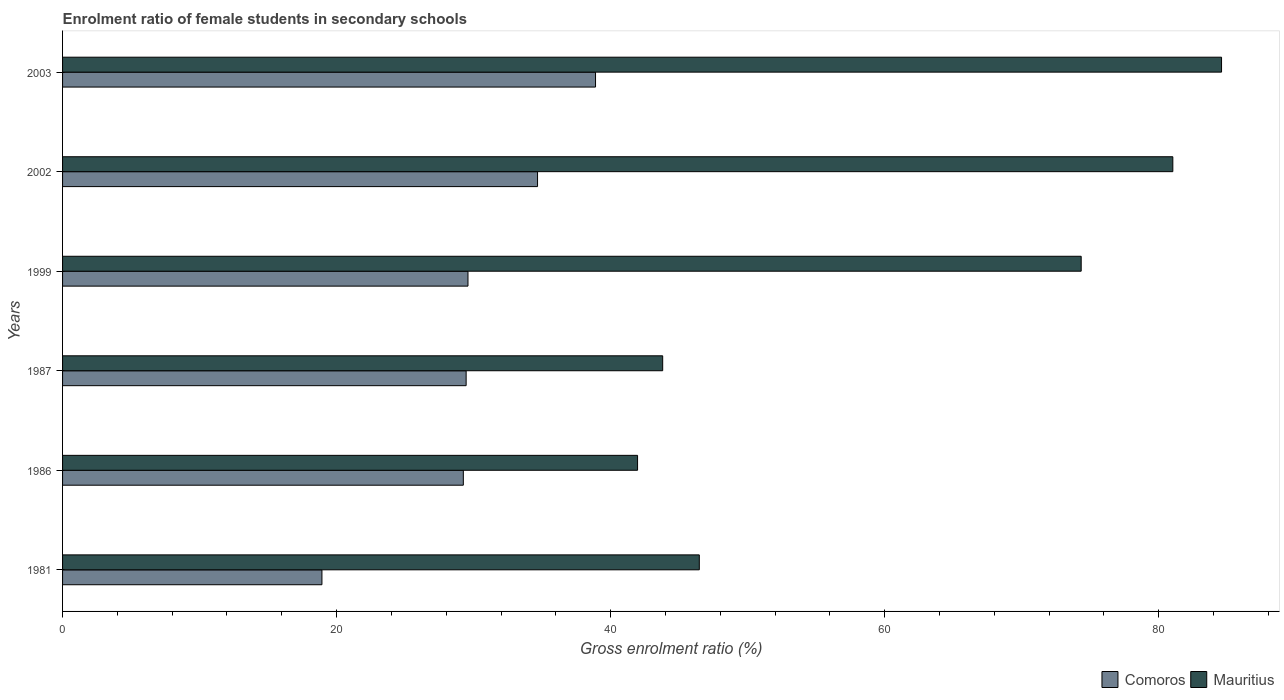Are the number of bars on each tick of the Y-axis equal?
Give a very brief answer. Yes. What is the label of the 2nd group of bars from the top?
Provide a succinct answer. 2002. What is the enrolment ratio of female students in secondary schools in Mauritius in 1999?
Ensure brevity in your answer.  74.34. Across all years, what is the maximum enrolment ratio of female students in secondary schools in Mauritius?
Offer a very short reply. 84.59. Across all years, what is the minimum enrolment ratio of female students in secondary schools in Comoros?
Your answer should be compact. 18.93. In which year was the enrolment ratio of female students in secondary schools in Mauritius maximum?
Your response must be concise. 2003. In which year was the enrolment ratio of female students in secondary schools in Comoros minimum?
Provide a succinct answer. 1981. What is the total enrolment ratio of female students in secondary schools in Comoros in the graph?
Your answer should be very brief. 180.79. What is the difference between the enrolment ratio of female students in secondary schools in Comoros in 1981 and that in 2002?
Your response must be concise. -15.74. What is the difference between the enrolment ratio of female students in secondary schools in Mauritius in 1999 and the enrolment ratio of female students in secondary schools in Comoros in 2002?
Provide a short and direct response. 39.68. What is the average enrolment ratio of female students in secondary schools in Mauritius per year?
Your answer should be very brief. 62.03. In the year 2002, what is the difference between the enrolment ratio of female students in secondary schools in Mauritius and enrolment ratio of female students in secondary schools in Comoros?
Your response must be concise. 46.37. What is the ratio of the enrolment ratio of female students in secondary schools in Mauritius in 1981 to that in 1986?
Give a very brief answer. 1.11. Is the enrolment ratio of female students in secondary schools in Comoros in 1986 less than that in 2003?
Make the answer very short. Yes. What is the difference between the highest and the second highest enrolment ratio of female students in secondary schools in Mauritius?
Ensure brevity in your answer.  3.56. What is the difference between the highest and the lowest enrolment ratio of female students in secondary schools in Mauritius?
Give a very brief answer. 42.62. What does the 2nd bar from the top in 1999 represents?
Offer a terse response. Comoros. What does the 2nd bar from the bottom in 1986 represents?
Your answer should be very brief. Mauritius. Are all the bars in the graph horizontal?
Provide a short and direct response. Yes. How many years are there in the graph?
Give a very brief answer. 6. Are the values on the major ticks of X-axis written in scientific E-notation?
Provide a short and direct response. No. Does the graph contain any zero values?
Your response must be concise. No. Where does the legend appear in the graph?
Your response must be concise. Bottom right. How many legend labels are there?
Give a very brief answer. 2. What is the title of the graph?
Offer a very short reply. Enrolment ratio of female students in secondary schools. What is the Gross enrolment ratio (%) of Comoros in 1981?
Provide a short and direct response. 18.93. What is the Gross enrolment ratio (%) in Mauritius in 1981?
Your answer should be very brief. 46.47. What is the Gross enrolment ratio (%) of Comoros in 1986?
Provide a short and direct response. 29.25. What is the Gross enrolment ratio (%) of Mauritius in 1986?
Offer a terse response. 41.97. What is the Gross enrolment ratio (%) in Comoros in 1987?
Your response must be concise. 29.45. What is the Gross enrolment ratio (%) of Mauritius in 1987?
Offer a terse response. 43.8. What is the Gross enrolment ratio (%) of Comoros in 1999?
Your answer should be compact. 29.59. What is the Gross enrolment ratio (%) in Mauritius in 1999?
Provide a short and direct response. 74.34. What is the Gross enrolment ratio (%) of Comoros in 2002?
Your answer should be very brief. 34.67. What is the Gross enrolment ratio (%) in Mauritius in 2002?
Your response must be concise. 81.03. What is the Gross enrolment ratio (%) in Comoros in 2003?
Give a very brief answer. 38.9. What is the Gross enrolment ratio (%) of Mauritius in 2003?
Make the answer very short. 84.59. Across all years, what is the maximum Gross enrolment ratio (%) in Comoros?
Offer a very short reply. 38.9. Across all years, what is the maximum Gross enrolment ratio (%) in Mauritius?
Your answer should be compact. 84.59. Across all years, what is the minimum Gross enrolment ratio (%) of Comoros?
Offer a very short reply. 18.93. Across all years, what is the minimum Gross enrolment ratio (%) of Mauritius?
Provide a succinct answer. 41.97. What is the total Gross enrolment ratio (%) of Comoros in the graph?
Offer a very short reply. 180.79. What is the total Gross enrolment ratio (%) of Mauritius in the graph?
Your answer should be compact. 372.2. What is the difference between the Gross enrolment ratio (%) of Comoros in 1981 and that in 1986?
Provide a short and direct response. -10.32. What is the difference between the Gross enrolment ratio (%) in Mauritius in 1981 and that in 1986?
Offer a terse response. 4.51. What is the difference between the Gross enrolment ratio (%) of Comoros in 1981 and that in 1987?
Offer a terse response. -10.52. What is the difference between the Gross enrolment ratio (%) of Mauritius in 1981 and that in 1987?
Ensure brevity in your answer.  2.67. What is the difference between the Gross enrolment ratio (%) of Comoros in 1981 and that in 1999?
Offer a very short reply. -10.66. What is the difference between the Gross enrolment ratio (%) of Mauritius in 1981 and that in 1999?
Your response must be concise. -27.87. What is the difference between the Gross enrolment ratio (%) in Comoros in 1981 and that in 2002?
Provide a succinct answer. -15.74. What is the difference between the Gross enrolment ratio (%) of Mauritius in 1981 and that in 2002?
Provide a short and direct response. -34.56. What is the difference between the Gross enrolment ratio (%) in Comoros in 1981 and that in 2003?
Offer a very short reply. -19.97. What is the difference between the Gross enrolment ratio (%) of Mauritius in 1981 and that in 2003?
Offer a very short reply. -38.12. What is the difference between the Gross enrolment ratio (%) in Comoros in 1986 and that in 1987?
Your response must be concise. -0.2. What is the difference between the Gross enrolment ratio (%) of Mauritius in 1986 and that in 1987?
Make the answer very short. -1.83. What is the difference between the Gross enrolment ratio (%) of Comoros in 1986 and that in 1999?
Offer a terse response. -0.34. What is the difference between the Gross enrolment ratio (%) of Mauritius in 1986 and that in 1999?
Your response must be concise. -32.38. What is the difference between the Gross enrolment ratio (%) in Comoros in 1986 and that in 2002?
Ensure brevity in your answer.  -5.42. What is the difference between the Gross enrolment ratio (%) of Mauritius in 1986 and that in 2002?
Provide a succinct answer. -39.07. What is the difference between the Gross enrolment ratio (%) of Comoros in 1986 and that in 2003?
Offer a very short reply. -9.65. What is the difference between the Gross enrolment ratio (%) of Mauritius in 1986 and that in 2003?
Keep it short and to the point. -42.62. What is the difference between the Gross enrolment ratio (%) of Comoros in 1987 and that in 1999?
Provide a succinct answer. -0.13. What is the difference between the Gross enrolment ratio (%) of Mauritius in 1987 and that in 1999?
Your answer should be compact. -30.55. What is the difference between the Gross enrolment ratio (%) of Comoros in 1987 and that in 2002?
Give a very brief answer. -5.21. What is the difference between the Gross enrolment ratio (%) of Mauritius in 1987 and that in 2002?
Give a very brief answer. -37.23. What is the difference between the Gross enrolment ratio (%) of Comoros in 1987 and that in 2003?
Ensure brevity in your answer.  -9.44. What is the difference between the Gross enrolment ratio (%) of Mauritius in 1987 and that in 2003?
Provide a short and direct response. -40.79. What is the difference between the Gross enrolment ratio (%) of Comoros in 1999 and that in 2002?
Make the answer very short. -5.08. What is the difference between the Gross enrolment ratio (%) of Mauritius in 1999 and that in 2002?
Your answer should be compact. -6.69. What is the difference between the Gross enrolment ratio (%) of Comoros in 1999 and that in 2003?
Provide a short and direct response. -9.31. What is the difference between the Gross enrolment ratio (%) of Mauritius in 1999 and that in 2003?
Your answer should be very brief. -10.24. What is the difference between the Gross enrolment ratio (%) in Comoros in 2002 and that in 2003?
Give a very brief answer. -4.23. What is the difference between the Gross enrolment ratio (%) in Mauritius in 2002 and that in 2003?
Make the answer very short. -3.56. What is the difference between the Gross enrolment ratio (%) in Comoros in 1981 and the Gross enrolment ratio (%) in Mauritius in 1986?
Provide a succinct answer. -23.04. What is the difference between the Gross enrolment ratio (%) of Comoros in 1981 and the Gross enrolment ratio (%) of Mauritius in 1987?
Offer a terse response. -24.87. What is the difference between the Gross enrolment ratio (%) in Comoros in 1981 and the Gross enrolment ratio (%) in Mauritius in 1999?
Provide a succinct answer. -55.41. What is the difference between the Gross enrolment ratio (%) of Comoros in 1981 and the Gross enrolment ratio (%) of Mauritius in 2002?
Keep it short and to the point. -62.1. What is the difference between the Gross enrolment ratio (%) of Comoros in 1981 and the Gross enrolment ratio (%) of Mauritius in 2003?
Your response must be concise. -65.66. What is the difference between the Gross enrolment ratio (%) in Comoros in 1986 and the Gross enrolment ratio (%) in Mauritius in 1987?
Provide a succinct answer. -14.55. What is the difference between the Gross enrolment ratio (%) in Comoros in 1986 and the Gross enrolment ratio (%) in Mauritius in 1999?
Ensure brevity in your answer.  -45.09. What is the difference between the Gross enrolment ratio (%) of Comoros in 1986 and the Gross enrolment ratio (%) of Mauritius in 2002?
Make the answer very short. -51.78. What is the difference between the Gross enrolment ratio (%) of Comoros in 1986 and the Gross enrolment ratio (%) of Mauritius in 2003?
Your response must be concise. -55.34. What is the difference between the Gross enrolment ratio (%) in Comoros in 1987 and the Gross enrolment ratio (%) in Mauritius in 1999?
Your response must be concise. -44.89. What is the difference between the Gross enrolment ratio (%) in Comoros in 1987 and the Gross enrolment ratio (%) in Mauritius in 2002?
Ensure brevity in your answer.  -51.58. What is the difference between the Gross enrolment ratio (%) in Comoros in 1987 and the Gross enrolment ratio (%) in Mauritius in 2003?
Your answer should be compact. -55.13. What is the difference between the Gross enrolment ratio (%) in Comoros in 1999 and the Gross enrolment ratio (%) in Mauritius in 2002?
Ensure brevity in your answer.  -51.44. What is the difference between the Gross enrolment ratio (%) in Comoros in 1999 and the Gross enrolment ratio (%) in Mauritius in 2003?
Offer a terse response. -55. What is the difference between the Gross enrolment ratio (%) in Comoros in 2002 and the Gross enrolment ratio (%) in Mauritius in 2003?
Give a very brief answer. -49.92. What is the average Gross enrolment ratio (%) in Comoros per year?
Provide a succinct answer. 30.13. What is the average Gross enrolment ratio (%) of Mauritius per year?
Ensure brevity in your answer.  62.03. In the year 1981, what is the difference between the Gross enrolment ratio (%) of Comoros and Gross enrolment ratio (%) of Mauritius?
Your answer should be very brief. -27.54. In the year 1986, what is the difference between the Gross enrolment ratio (%) in Comoros and Gross enrolment ratio (%) in Mauritius?
Give a very brief answer. -12.72. In the year 1987, what is the difference between the Gross enrolment ratio (%) of Comoros and Gross enrolment ratio (%) of Mauritius?
Offer a terse response. -14.34. In the year 1999, what is the difference between the Gross enrolment ratio (%) in Comoros and Gross enrolment ratio (%) in Mauritius?
Give a very brief answer. -44.76. In the year 2002, what is the difference between the Gross enrolment ratio (%) of Comoros and Gross enrolment ratio (%) of Mauritius?
Your response must be concise. -46.37. In the year 2003, what is the difference between the Gross enrolment ratio (%) in Comoros and Gross enrolment ratio (%) in Mauritius?
Provide a short and direct response. -45.69. What is the ratio of the Gross enrolment ratio (%) in Comoros in 1981 to that in 1986?
Give a very brief answer. 0.65. What is the ratio of the Gross enrolment ratio (%) in Mauritius in 1981 to that in 1986?
Keep it short and to the point. 1.11. What is the ratio of the Gross enrolment ratio (%) in Comoros in 1981 to that in 1987?
Ensure brevity in your answer.  0.64. What is the ratio of the Gross enrolment ratio (%) in Mauritius in 1981 to that in 1987?
Keep it short and to the point. 1.06. What is the ratio of the Gross enrolment ratio (%) of Comoros in 1981 to that in 1999?
Your answer should be compact. 0.64. What is the ratio of the Gross enrolment ratio (%) of Mauritius in 1981 to that in 1999?
Your response must be concise. 0.63. What is the ratio of the Gross enrolment ratio (%) of Comoros in 1981 to that in 2002?
Offer a very short reply. 0.55. What is the ratio of the Gross enrolment ratio (%) of Mauritius in 1981 to that in 2002?
Keep it short and to the point. 0.57. What is the ratio of the Gross enrolment ratio (%) of Comoros in 1981 to that in 2003?
Your answer should be very brief. 0.49. What is the ratio of the Gross enrolment ratio (%) of Mauritius in 1981 to that in 2003?
Ensure brevity in your answer.  0.55. What is the ratio of the Gross enrolment ratio (%) of Comoros in 1986 to that in 1987?
Provide a short and direct response. 0.99. What is the ratio of the Gross enrolment ratio (%) of Mauritius in 1986 to that in 1987?
Your response must be concise. 0.96. What is the ratio of the Gross enrolment ratio (%) of Mauritius in 1986 to that in 1999?
Provide a succinct answer. 0.56. What is the ratio of the Gross enrolment ratio (%) of Comoros in 1986 to that in 2002?
Ensure brevity in your answer.  0.84. What is the ratio of the Gross enrolment ratio (%) in Mauritius in 1986 to that in 2002?
Offer a very short reply. 0.52. What is the ratio of the Gross enrolment ratio (%) of Comoros in 1986 to that in 2003?
Offer a terse response. 0.75. What is the ratio of the Gross enrolment ratio (%) in Mauritius in 1986 to that in 2003?
Your answer should be very brief. 0.5. What is the ratio of the Gross enrolment ratio (%) of Comoros in 1987 to that in 1999?
Give a very brief answer. 1. What is the ratio of the Gross enrolment ratio (%) of Mauritius in 1987 to that in 1999?
Make the answer very short. 0.59. What is the ratio of the Gross enrolment ratio (%) in Comoros in 1987 to that in 2002?
Your answer should be very brief. 0.85. What is the ratio of the Gross enrolment ratio (%) in Mauritius in 1987 to that in 2002?
Provide a short and direct response. 0.54. What is the ratio of the Gross enrolment ratio (%) in Comoros in 1987 to that in 2003?
Offer a terse response. 0.76. What is the ratio of the Gross enrolment ratio (%) in Mauritius in 1987 to that in 2003?
Provide a short and direct response. 0.52. What is the ratio of the Gross enrolment ratio (%) of Comoros in 1999 to that in 2002?
Ensure brevity in your answer.  0.85. What is the ratio of the Gross enrolment ratio (%) of Mauritius in 1999 to that in 2002?
Keep it short and to the point. 0.92. What is the ratio of the Gross enrolment ratio (%) of Comoros in 1999 to that in 2003?
Provide a succinct answer. 0.76. What is the ratio of the Gross enrolment ratio (%) of Mauritius in 1999 to that in 2003?
Your response must be concise. 0.88. What is the ratio of the Gross enrolment ratio (%) in Comoros in 2002 to that in 2003?
Provide a succinct answer. 0.89. What is the ratio of the Gross enrolment ratio (%) in Mauritius in 2002 to that in 2003?
Ensure brevity in your answer.  0.96. What is the difference between the highest and the second highest Gross enrolment ratio (%) of Comoros?
Provide a succinct answer. 4.23. What is the difference between the highest and the second highest Gross enrolment ratio (%) in Mauritius?
Give a very brief answer. 3.56. What is the difference between the highest and the lowest Gross enrolment ratio (%) in Comoros?
Make the answer very short. 19.97. What is the difference between the highest and the lowest Gross enrolment ratio (%) in Mauritius?
Ensure brevity in your answer.  42.62. 